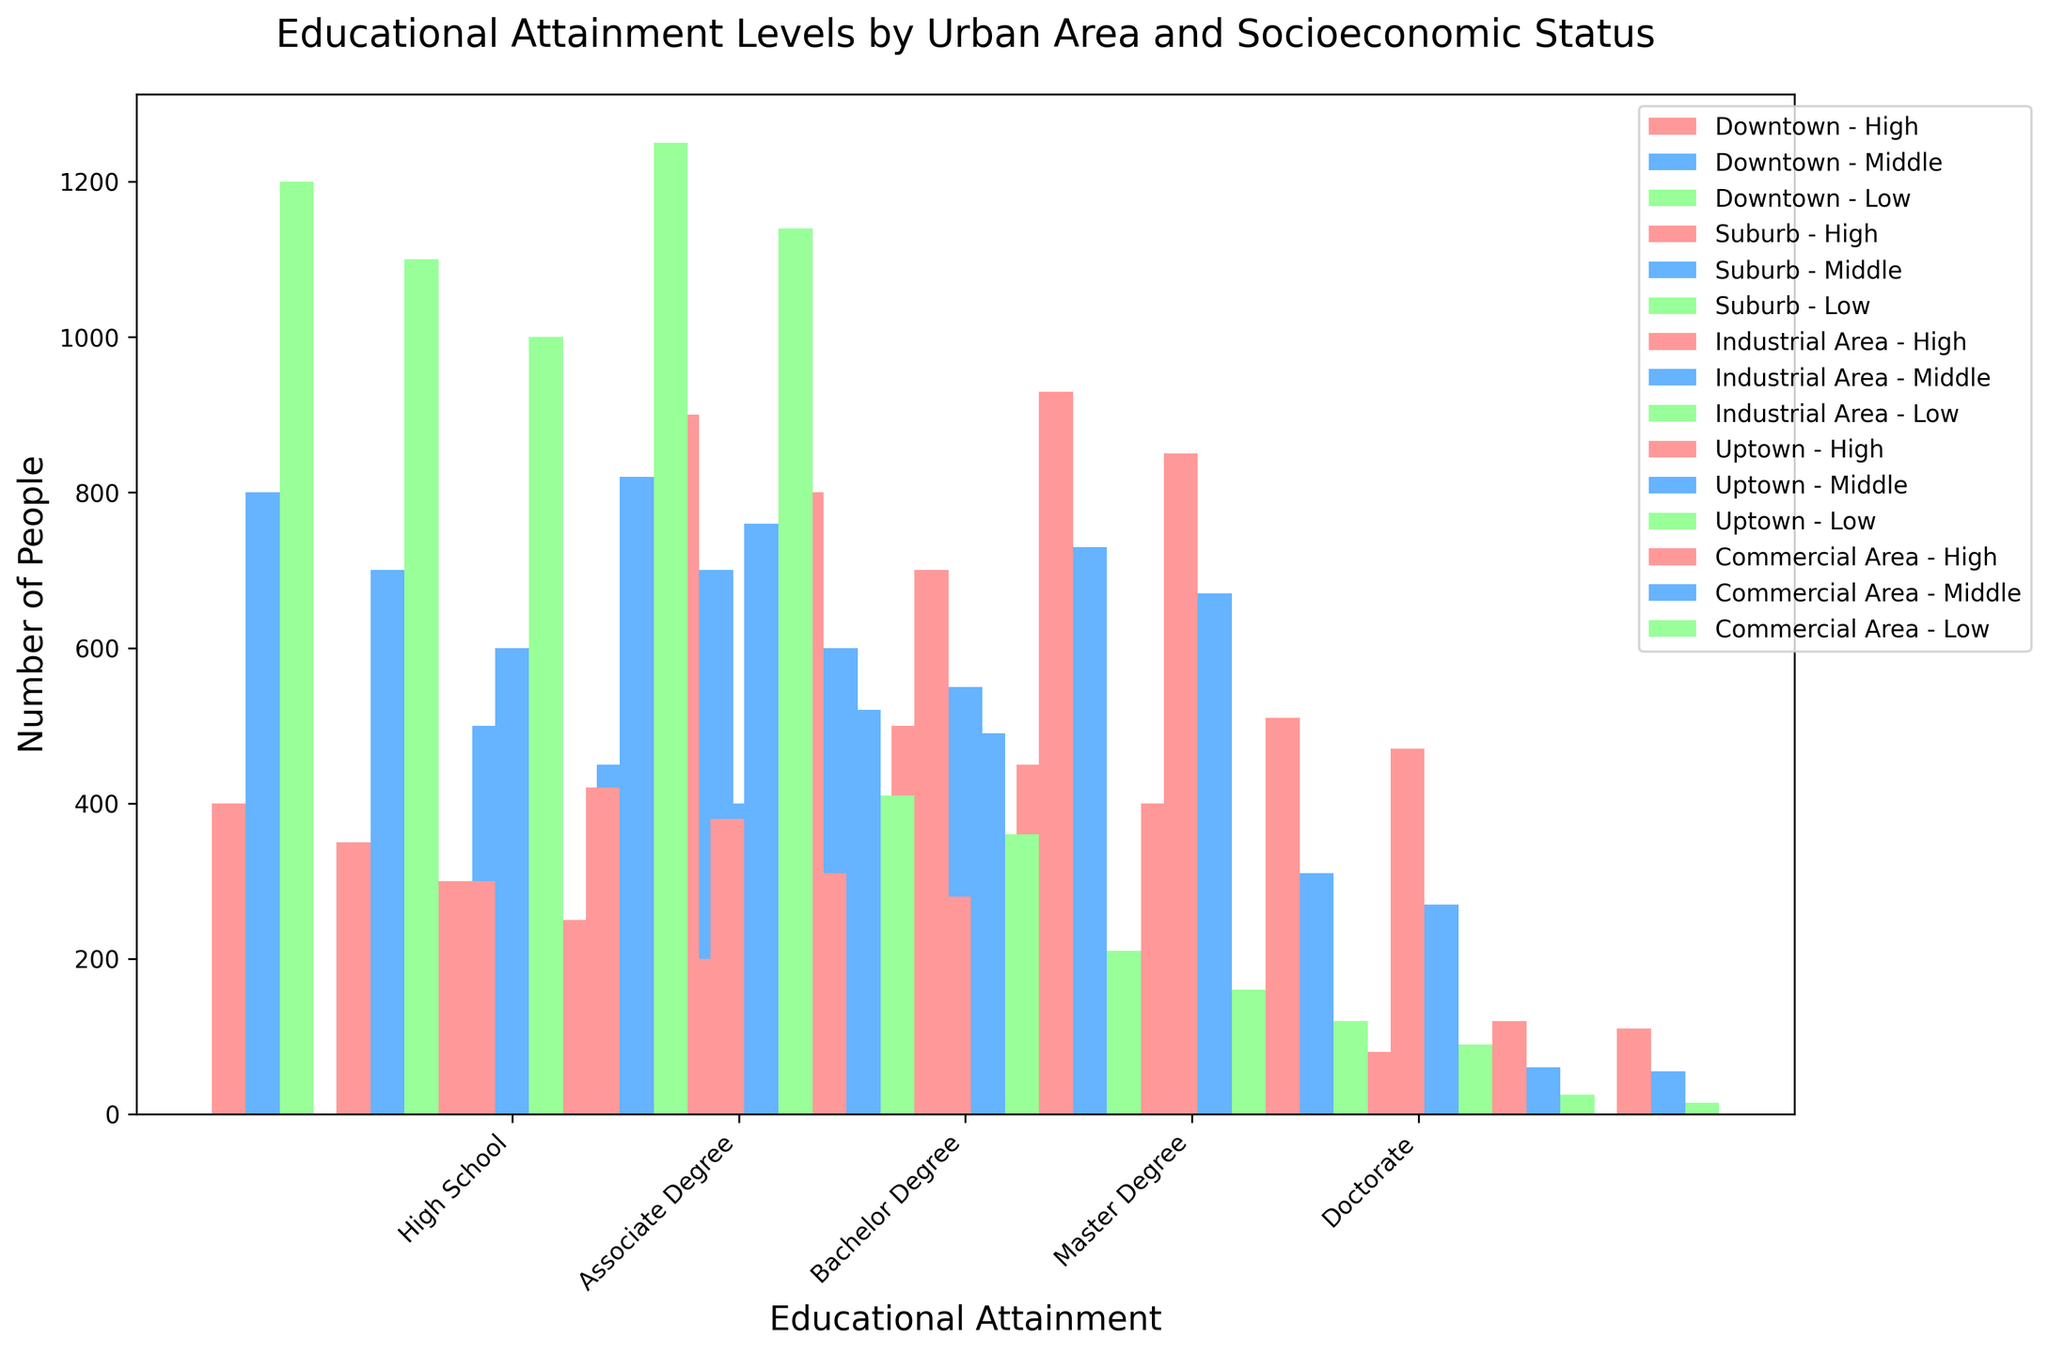What's the most common educational attainment level for low socioeconomic status residents in Suburb? Locate the bars representing low socioeconomic status in the Suburb across all education levels. Identify which bar is the tallest. The tallest bar corresponds to the most common educational attainment level.
Answer: High School Which area has the highest number of residents with a Bachelor Degree among high socioeconomic status? Look at all the bars representing high socioeconomic status in each area and find the tallest bar for the Bachelor Degree category. Compare the heights to determine the highest one.
Answer: Downtown Which socioeconomic status group has the lowest number of people with an Associate Degree in Uptown? Compare the heights of the bars representing different socioeconomic statuses within Uptown for the Associate Degree category. The shortest bar indicates the lowest number of people.
Answer: Low How many residents have a Master Degree in Uptown and Commercial Area combined for middle socioeconomic status? Add the values of the middle socioeconomic status bars in the Master Degree category for both Uptown and Commercial Area.
Answer: 310 + 270 = 580 Compare the number of high socioeconomic status residents with a Doctorate in Downtown and Industrial Area. Which has more? Look at the bars for high socioeconomic status residents with a Doctorate in both Downtown and Industrial Area and compare their heights.
Answer: Downtown What is the difference in the number of people with a Bachelor Degree between high and low socioeconomic statuses in the Commercial Area? Subtract the number of people with a Bachelor Degree in low socioeconomic status from those in high socioeconomic status within the Commercial Area.
Answer: 850 - 160 = 690 Which area shows the highest educational diversity (defined as having a relatively even distribution across educational attainment levels) for middle socioeconomic status? Examine the middle socioeconomic status bars across all educational attainment levels for each area. Identify the area where the heights of the bars are most evenly distributed.
Answer: Downtown In which area and socioeconomic status combination is achieving a Master Degree the least common? Identify the smallest bars in the Master Degree category across all areas and socioeconomic statuses. Compare to find the absolute lowest.
Answer: Industrial Area, Low 